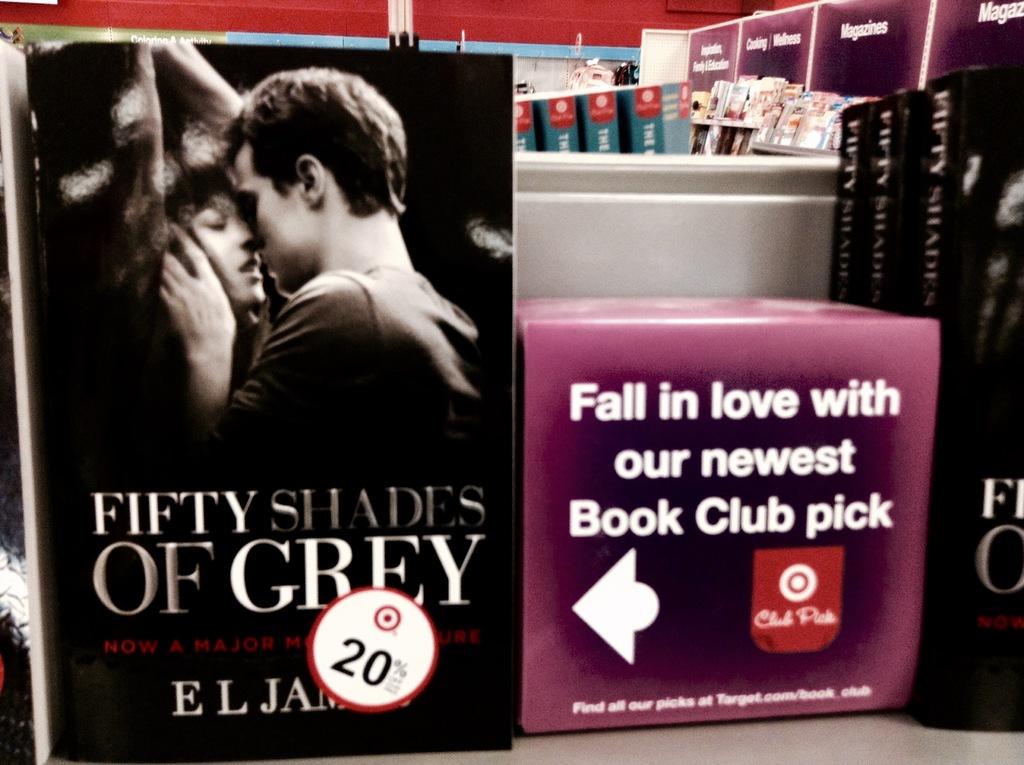What is the newest book club pick?
Offer a terse response. Fifty shades of grey. Where can i find all my book club pics at?
Provide a succinct answer. Target. 